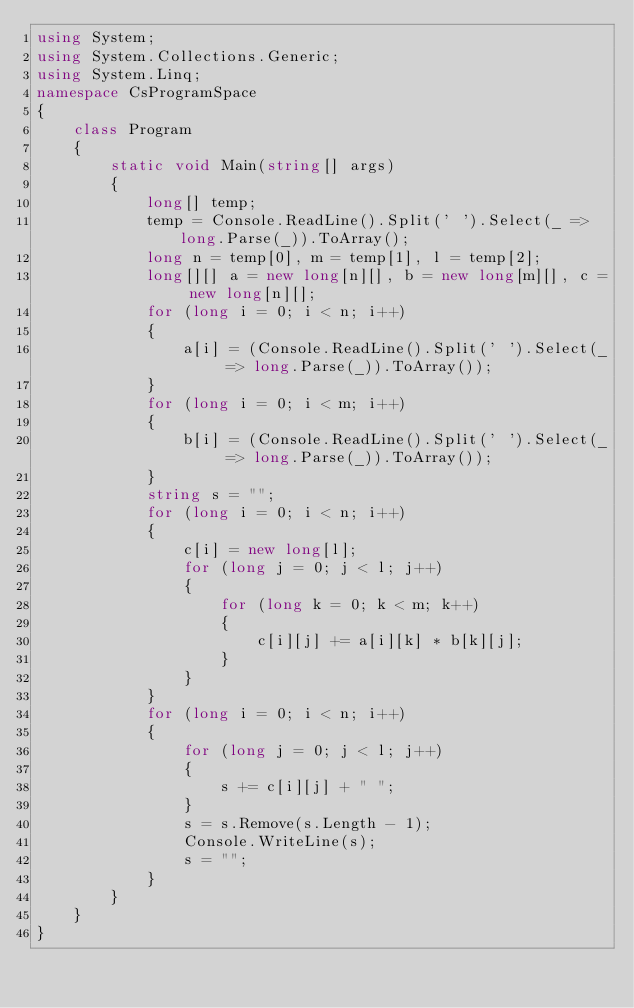Convert code to text. <code><loc_0><loc_0><loc_500><loc_500><_C#_>using System;
using System.Collections.Generic;
using System.Linq;
namespace CsProgramSpace
{
    class Program
    {
        static void Main(string[] args)
        {
            long[] temp;
            temp = Console.ReadLine().Split(' ').Select(_ => long.Parse(_)).ToArray();
            long n = temp[0], m = temp[1], l = temp[2];
            long[][] a = new long[n][], b = new long[m][], c = new long[n][];
            for (long i = 0; i < n; i++)
            {
                a[i] = (Console.ReadLine().Split(' ').Select(_ => long.Parse(_)).ToArray());
            }
            for (long i = 0; i < m; i++)
            {
                b[i] = (Console.ReadLine().Split(' ').Select(_ => long.Parse(_)).ToArray());
            }
            string s = "";
            for (long i = 0; i < n; i++)
            {
                c[i] = new long[l];
                for (long j = 0; j < l; j++)
                {
                    for (long k = 0; k < m; k++)
                    {
                        c[i][j] += a[i][k] * b[k][j];
                    }
                }
            }
            for (long i = 0; i < n; i++)
            {
                for (long j = 0; j < l; j++)
                {
                    s += c[i][j] + " ";
                }
                s = s.Remove(s.Length - 1);
                Console.WriteLine(s);
                s = "";
            }
        }
    }
}
</code> 